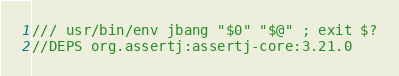Convert code to text. <code><loc_0><loc_0><loc_500><loc_500><_Java_>/// usr/bin/env jbang "$0" "$@" ; exit $?
//DEPS org.assertj:assertj-core:3.21.0</code> 